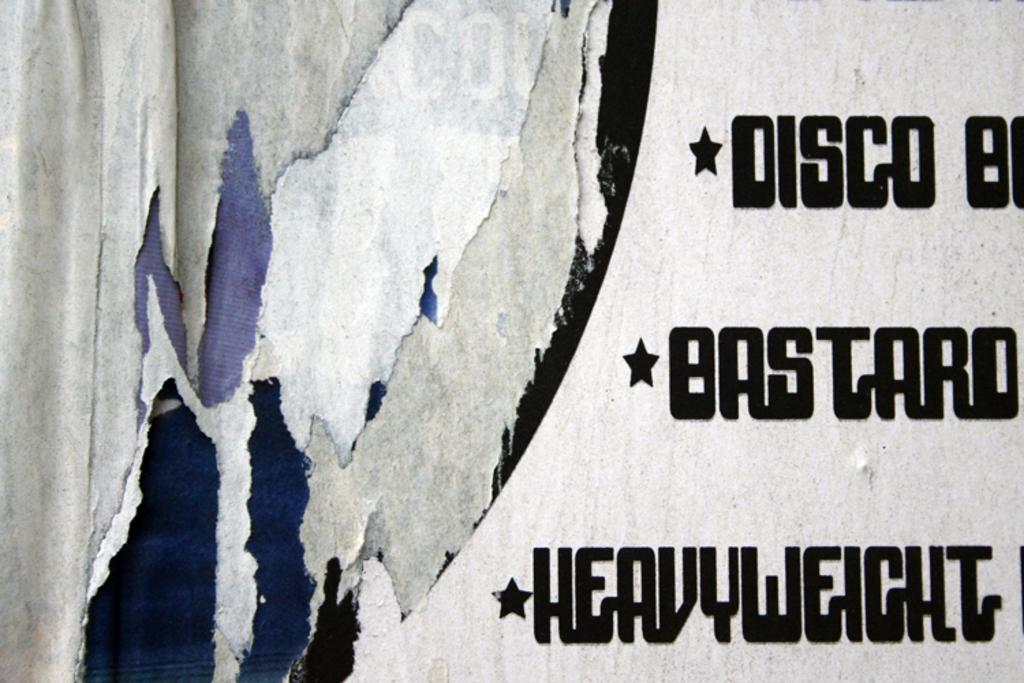<image>
Relay a brief, clear account of the picture shown. A painting with several bullet points, one of which is Disco. 